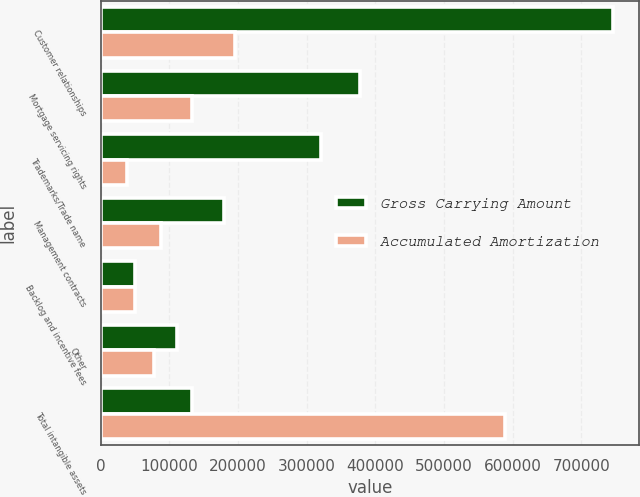Convert chart. <chart><loc_0><loc_0><loc_500><loc_500><stacked_bar_chart><ecel><fcel>Customer relationships<fcel>Mortgage servicing rights<fcel>Trademarks/Trade name<fcel>Management contracts<fcel>Backlog and incentive fees<fcel>Other<fcel>Total intangible assets<nl><fcel>Gross Carrying Amount<fcel>746814<fcel>377995<fcel>320306<fcel>180099<fcel>49667<fcel>110731<fcel>133272<nl><fcel>Accumulated Amortization<fcel>195056<fcel>133272<fcel>38581<fcel>87687<fcel>49667<fcel>76779<fcel>589236<nl></chart> 